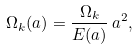Convert formula to latex. <formula><loc_0><loc_0><loc_500><loc_500>\Omega _ { k } ( a ) = \frac { \Omega _ { k } } { E ( a ) } \, a ^ { 2 } ,</formula> 